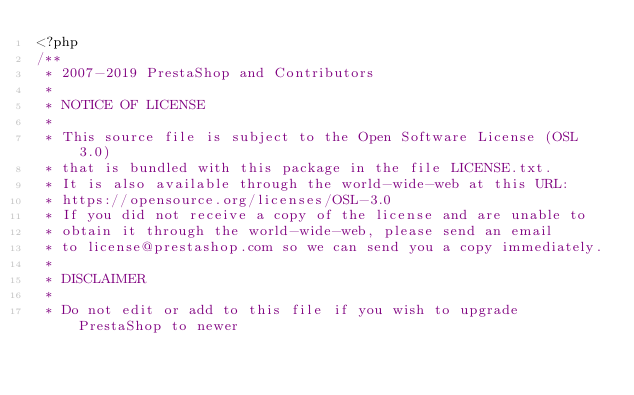<code> <loc_0><loc_0><loc_500><loc_500><_PHP_><?php
/**
 * 2007-2019 PrestaShop and Contributors
 *
 * NOTICE OF LICENSE
 *
 * This source file is subject to the Open Software License (OSL 3.0)
 * that is bundled with this package in the file LICENSE.txt.
 * It is also available through the world-wide-web at this URL:
 * https://opensource.org/licenses/OSL-3.0
 * If you did not receive a copy of the license and are unable to
 * obtain it through the world-wide-web, please send an email
 * to license@prestashop.com so we can send you a copy immediately.
 *
 * DISCLAIMER
 *
 * Do not edit or add to this file if you wish to upgrade PrestaShop to newer</code> 